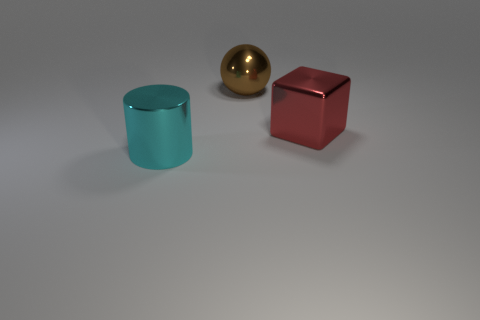Add 3 tiny red metal blocks. How many objects exist? 6 Subtract 1 balls. How many balls are left? 0 Subtract 1 red cubes. How many objects are left? 2 Subtract all balls. How many objects are left? 2 Subtract all red balls. Subtract all yellow cylinders. How many balls are left? 1 Subtract all big brown shiny objects. Subtract all red metallic blocks. How many objects are left? 1 Add 2 shiny cylinders. How many shiny cylinders are left? 3 Add 2 big shiny cylinders. How many big shiny cylinders exist? 3 